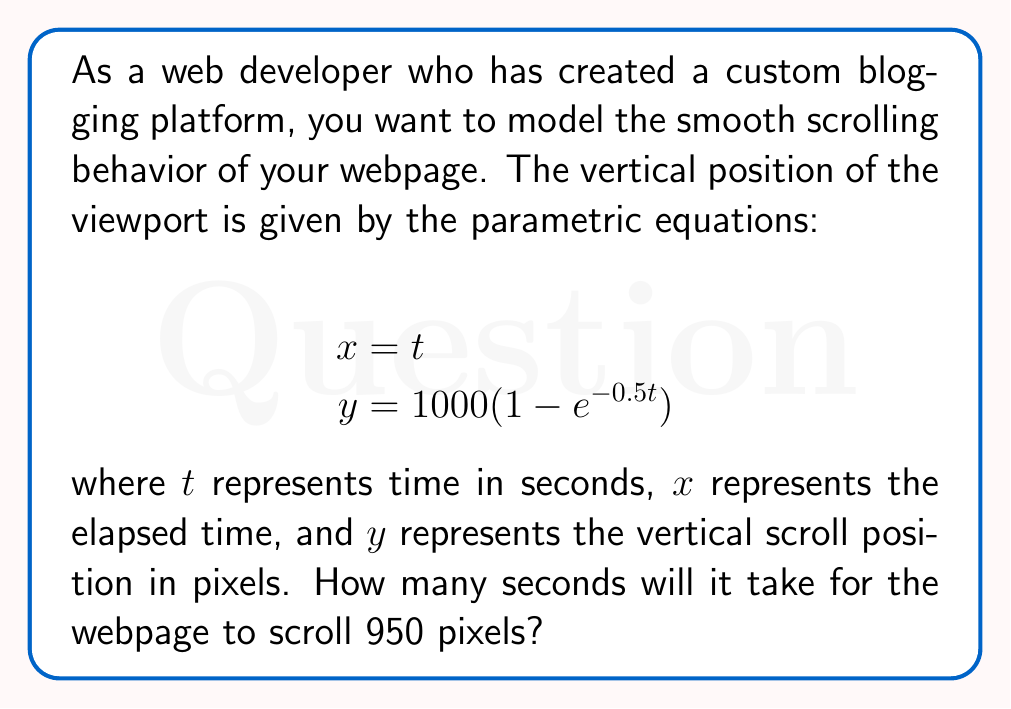Help me with this question. To solve this problem, we need to follow these steps:

1) We're looking for the time $t$ when $y = 950$ pixels. Let's set up the equation:

   $$950 = 1000(1 - e^{-0.5t})$$

2) Divide both sides by 1000:

   $$0.95 = 1 - e^{-0.5t}$$

3) Subtract both sides from 1:

   $$0.05 = e^{-0.5t}$$

4) Take the natural logarithm of both sides:

   $$\ln(0.05) = -0.5t$$

5) Solve for $t$:

   $$t = -\frac{\ln(0.05)}{0.5}$$

6) Calculate the value:

   $$t = -\frac{\ln(0.05)}{0.5} \approx 5.99$$

Therefore, it will take approximately 5.99 seconds for the webpage to scroll 950 pixels.
Answer: $t \approx 5.99$ seconds 